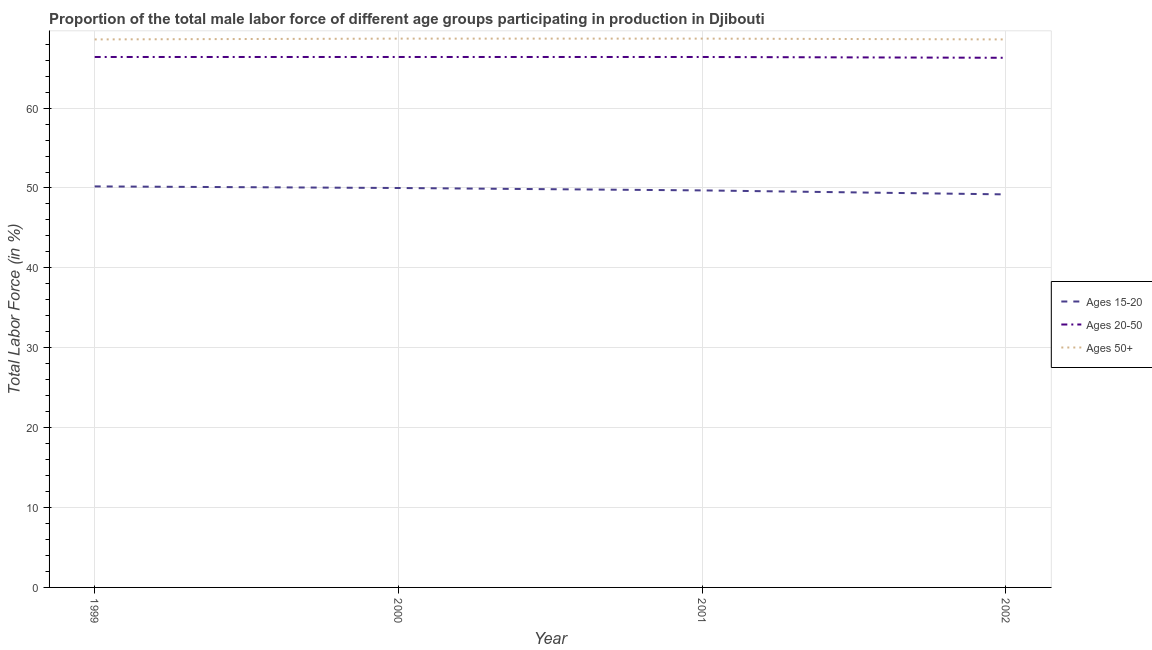How many different coloured lines are there?
Your response must be concise. 3. Is the number of lines equal to the number of legend labels?
Keep it short and to the point. Yes. What is the percentage of male labor force within the age group 15-20 in 2000?
Keep it short and to the point. 50. Across all years, what is the maximum percentage of male labor force above age 50?
Your response must be concise. 68.7. Across all years, what is the minimum percentage of male labor force above age 50?
Ensure brevity in your answer.  68.6. In which year was the percentage of male labor force within the age group 15-20 maximum?
Make the answer very short. 1999. In which year was the percentage of male labor force within the age group 20-50 minimum?
Your answer should be very brief. 2002. What is the total percentage of male labor force within the age group 15-20 in the graph?
Your response must be concise. 199.1. What is the difference between the percentage of male labor force within the age group 15-20 in 2001 and that in 2002?
Your response must be concise. 0.5. What is the difference between the percentage of male labor force within the age group 20-50 in 2001 and the percentage of male labor force above age 50 in 2002?
Offer a very short reply. -2.2. What is the average percentage of male labor force within the age group 15-20 per year?
Make the answer very short. 49.78. In the year 2001, what is the difference between the percentage of male labor force above age 50 and percentage of male labor force within the age group 15-20?
Provide a short and direct response. 19. What is the ratio of the percentage of male labor force within the age group 15-20 in 1999 to that in 2000?
Your answer should be very brief. 1. Is the difference between the percentage of male labor force above age 50 in 1999 and 2002 greater than the difference between the percentage of male labor force within the age group 15-20 in 1999 and 2002?
Provide a succinct answer. No. What is the difference between the highest and the second highest percentage of male labor force within the age group 15-20?
Make the answer very short. 0.2. What is the difference between the highest and the lowest percentage of male labor force within the age group 20-50?
Give a very brief answer. 0.1. In how many years, is the percentage of male labor force within the age group 20-50 greater than the average percentage of male labor force within the age group 20-50 taken over all years?
Offer a very short reply. 3. Is it the case that in every year, the sum of the percentage of male labor force within the age group 15-20 and percentage of male labor force within the age group 20-50 is greater than the percentage of male labor force above age 50?
Your answer should be very brief. Yes. Does the percentage of male labor force within the age group 15-20 monotonically increase over the years?
Provide a succinct answer. No. Is the percentage of male labor force within the age group 15-20 strictly greater than the percentage of male labor force above age 50 over the years?
Your answer should be compact. No. Is the percentage of male labor force within the age group 20-50 strictly less than the percentage of male labor force within the age group 15-20 over the years?
Offer a very short reply. No. How many lines are there?
Your answer should be compact. 3. How many years are there in the graph?
Offer a terse response. 4. Are the values on the major ticks of Y-axis written in scientific E-notation?
Make the answer very short. No. Does the graph contain any zero values?
Your answer should be compact. No. Does the graph contain grids?
Your answer should be very brief. Yes. Where does the legend appear in the graph?
Your answer should be compact. Center right. How are the legend labels stacked?
Give a very brief answer. Vertical. What is the title of the graph?
Provide a short and direct response. Proportion of the total male labor force of different age groups participating in production in Djibouti. Does "Tertiary education" appear as one of the legend labels in the graph?
Provide a short and direct response. No. What is the Total Labor Force (in %) of Ages 15-20 in 1999?
Ensure brevity in your answer.  50.2. What is the Total Labor Force (in %) of Ages 20-50 in 1999?
Offer a terse response. 66.4. What is the Total Labor Force (in %) in Ages 50+ in 1999?
Your answer should be very brief. 68.6. What is the Total Labor Force (in %) of Ages 15-20 in 2000?
Ensure brevity in your answer.  50. What is the Total Labor Force (in %) in Ages 20-50 in 2000?
Ensure brevity in your answer.  66.4. What is the Total Labor Force (in %) in Ages 50+ in 2000?
Offer a very short reply. 68.7. What is the Total Labor Force (in %) in Ages 15-20 in 2001?
Offer a terse response. 49.7. What is the Total Labor Force (in %) in Ages 20-50 in 2001?
Your answer should be compact. 66.4. What is the Total Labor Force (in %) in Ages 50+ in 2001?
Keep it short and to the point. 68.7. What is the Total Labor Force (in %) in Ages 15-20 in 2002?
Your response must be concise. 49.2. What is the Total Labor Force (in %) in Ages 20-50 in 2002?
Offer a very short reply. 66.3. What is the Total Labor Force (in %) in Ages 50+ in 2002?
Give a very brief answer. 68.6. Across all years, what is the maximum Total Labor Force (in %) of Ages 15-20?
Ensure brevity in your answer.  50.2. Across all years, what is the maximum Total Labor Force (in %) in Ages 20-50?
Your response must be concise. 66.4. Across all years, what is the maximum Total Labor Force (in %) of Ages 50+?
Offer a very short reply. 68.7. Across all years, what is the minimum Total Labor Force (in %) of Ages 15-20?
Your answer should be compact. 49.2. Across all years, what is the minimum Total Labor Force (in %) of Ages 20-50?
Offer a terse response. 66.3. Across all years, what is the minimum Total Labor Force (in %) of Ages 50+?
Ensure brevity in your answer.  68.6. What is the total Total Labor Force (in %) in Ages 15-20 in the graph?
Make the answer very short. 199.1. What is the total Total Labor Force (in %) in Ages 20-50 in the graph?
Your answer should be very brief. 265.5. What is the total Total Labor Force (in %) of Ages 50+ in the graph?
Your response must be concise. 274.6. What is the difference between the Total Labor Force (in %) in Ages 20-50 in 1999 and that in 2000?
Give a very brief answer. 0. What is the difference between the Total Labor Force (in %) in Ages 15-20 in 1999 and that in 2001?
Provide a succinct answer. 0.5. What is the difference between the Total Labor Force (in %) in Ages 20-50 in 1999 and that in 2001?
Offer a very short reply. 0. What is the difference between the Total Labor Force (in %) in Ages 50+ in 1999 and that in 2001?
Offer a very short reply. -0.1. What is the difference between the Total Labor Force (in %) of Ages 50+ in 1999 and that in 2002?
Provide a short and direct response. 0. What is the difference between the Total Labor Force (in %) of Ages 20-50 in 2000 and that in 2001?
Ensure brevity in your answer.  0. What is the difference between the Total Labor Force (in %) in Ages 15-20 in 2000 and that in 2002?
Your answer should be compact. 0.8. What is the difference between the Total Labor Force (in %) in Ages 15-20 in 2001 and that in 2002?
Ensure brevity in your answer.  0.5. What is the difference between the Total Labor Force (in %) in Ages 20-50 in 2001 and that in 2002?
Your response must be concise. 0.1. What is the difference between the Total Labor Force (in %) of Ages 50+ in 2001 and that in 2002?
Ensure brevity in your answer.  0.1. What is the difference between the Total Labor Force (in %) in Ages 15-20 in 1999 and the Total Labor Force (in %) in Ages 20-50 in 2000?
Your answer should be compact. -16.2. What is the difference between the Total Labor Force (in %) of Ages 15-20 in 1999 and the Total Labor Force (in %) of Ages 50+ in 2000?
Make the answer very short. -18.5. What is the difference between the Total Labor Force (in %) in Ages 20-50 in 1999 and the Total Labor Force (in %) in Ages 50+ in 2000?
Offer a very short reply. -2.3. What is the difference between the Total Labor Force (in %) of Ages 15-20 in 1999 and the Total Labor Force (in %) of Ages 20-50 in 2001?
Offer a very short reply. -16.2. What is the difference between the Total Labor Force (in %) of Ages 15-20 in 1999 and the Total Labor Force (in %) of Ages 50+ in 2001?
Provide a short and direct response. -18.5. What is the difference between the Total Labor Force (in %) in Ages 15-20 in 1999 and the Total Labor Force (in %) in Ages 20-50 in 2002?
Offer a very short reply. -16.1. What is the difference between the Total Labor Force (in %) in Ages 15-20 in 1999 and the Total Labor Force (in %) in Ages 50+ in 2002?
Keep it short and to the point. -18.4. What is the difference between the Total Labor Force (in %) of Ages 20-50 in 1999 and the Total Labor Force (in %) of Ages 50+ in 2002?
Your response must be concise. -2.2. What is the difference between the Total Labor Force (in %) in Ages 15-20 in 2000 and the Total Labor Force (in %) in Ages 20-50 in 2001?
Offer a very short reply. -16.4. What is the difference between the Total Labor Force (in %) of Ages 15-20 in 2000 and the Total Labor Force (in %) of Ages 50+ in 2001?
Provide a short and direct response. -18.7. What is the difference between the Total Labor Force (in %) in Ages 20-50 in 2000 and the Total Labor Force (in %) in Ages 50+ in 2001?
Provide a short and direct response. -2.3. What is the difference between the Total Labor Force (in %) of Ages 15-20 in 2000 and the Total Labor Force (in %) of Ages 20-50 in 2002?
Offer a very short reply. -16.3. What is the difference between the Total Labor Force (in %) of Ages 15-20 in 2000 and the Total Labor Force (in %) of Ages 50+ in 2002?
Offer a very short reply. -18.6. What is the difference between the Total Labor Force (in %) of Ages 20-50 in 2000 and the Total Labor Force (in %) of Ages 50+ in 2002?
Provide a short and direct response. -2.2. What is the difference between the Total Labor Force (in %) in Ages 15-20 in 2001 and the Total Labor Force (in %) in Ages 20-50 in 2002?
Your answer should be compact. -16.6. What is the difference between the Total Labor Force (in %) in Ages 15-20 in 2001 and the Total Labor Force (in %) in Ages 50+ in 2002?
Offer a very short reply. -18.9. What is the average Total Labor Force (in %) in Ages 15-20 per year?
Give a very brief answer. 49.77. What is the average Total Labor Force (in %) of Ages 20-50 per year?
Provide a short and direct response. 66.38. What is the average Total Labor Force (in %) of Ages 50+ per year?
Ensure brevity in your answer.  68.65. In the year 1999, what is the difference between the Total Labor Force (in %) of Ages 15-20 and Total Labor Force (in %) of Ages 20-50?
Your response must be concise. -16.2. In the year 1999, what is the difference between the Total Labor Force (in %) of Ages 15-20 and Total Labor Force (in %) of Ages 50+?
Provide a short and direct response. -18.4. In the year 1999, what is the difference between the Total Labor Force (in %) of Ages 20-50 and Total Labor Force (in %) of Ages 50+?
Your answer should be very brief. -2.2. In the year 2000, what is the difference between the Total Labor Force (in %) in Ages 15-20 and Total Labor Force (in %) in Ages 20-50?
Offer a very short reply. -16.4. In the year 2000, what is the difference between the Total Labor Force (in %) of Ages 15-20 and Total Labor Force (in %) of Ages 50+?
Provide a short and direct response. -18.7. In the year 2000, what is the difference between the Total Labor Force (in %) in Ages 20-50 and Total Labor Force (in %) in Ages 50+?
Your answer should be very brief. -2.3. In the year 2001, what is the difference between the Total Labor Force (in %) in Ages 15-20 and Total Labor Force (in %) in Ages 20-50?
Your answer should be very brief. -16.7. In the year 2001, what is the difference between the Total Labor Force (in %) in Ages 15-20 and Total Labor Force (in %) in Ages 50+?
Offer a very short reply. -19. In the year 2001, what is the difference between the Total Labor Force (in %) of Ages 20-50 and Total Labor Force (in %) of Ages 50+?
Provide a short and direct response. -2.3. In the year 2002, what is the difference between the Total Labor Force (in %) of Ages 15-20 and Total Labor Force (in %) of Ages 20-50?
Your answer should be very brief. -17.1. In the year 2002, what is the difference between the Total Labor Force (in %) of Ages 15-20 and Total Labor Force (in %) of Ages 50+?
Your answer should be compact. -19.4. In the year 2002, what is the difference between the Total Labor Force (in %) of Ages 20-50 and Total Labor Force (in %) of Ages 50+?
Offer a very short reply. -2.3. What is the ratio of the Total Labor Force (in %) in Ages 15-20 in 1999 to that in 2000?
Offer a very short reply. 1. What is the ratio of the Total Labor Force (in %) in Ages 50+ in 1999 to that in 2000?
Your response must be concise. 1. What is the ratio of the Total Labor Force (in %) in Ages 15-20 in 1999 to that in 2001?
Your response must be concise. 1.01. What is the ratio of the Total Labor Force (in %) of Ages 20-50 in 1999 to that in 2001?
Provide a short and direct response. 1. What is the ratio of the Total Labor Force (in %) of Ages 15-20 in 1999 to that in 2002?
Your response must be concise. 1.02. What is the ratio of the Total Labor Force (in %) in Ages 20-50 in 1999 to that in 2002?
Ensure brevity in your answer.  1. What is the ratio of the Total Labor Force (in %) in Ages 50+ in 1999 to that in 2002?
Provide a short and direct response. 1. What is the ratio of the Total Labor Force (in %) in Ages 15-20 in 2000 to that in 2001?
Your response must be concise. 1.01. What is the ratio of the Total Labor Force (in %) in Ages 20-50 in 2000 to that in 2001?
Your response must be concise. 1. What is the ratio of the Total Labor Force (in %) of Ages 50+ in 2000 to that in 2001?
Keep it short and to the point. 1. What is the ratio of the Total Labor Force (in %) of Ages 15-20 in 2000 to that in 2002?
Keep it short and to the point. 1.02. What is the ratio of the Total Labor Force (in %) of Ages 50+ in 2000 to that in 2002?
Your answer should be very brief. 1. What is the ratio of the Total Labor Force (in %) in Ages 15-20 in 2001 to that in 2002?
Your answer should be very brief. 1.01. What is the ratio of the Total Labor Force (in %) of Ages 20-50 in 2001 to that in 2002?
Ensure brevity in your answer.  1. What is the ratio of the Total Labor Force (in %) in Ages 50+ in 2001 to that in 2002?
Offer a terse response. 1. What is the difference between the highest and the second highest Total Labor Force (in %) of Ages 15-20?
Keep it short and to the point. 0.2. What is the difference between the highest and the lowest Total Labor Force (in %) of Ages 20-50?
Offer a very short reply. 0.1. What is the difference between the highest and the lowest Total Labor Force (in %) of Ages 50+?
Keep it short and to the point. 0.1. 